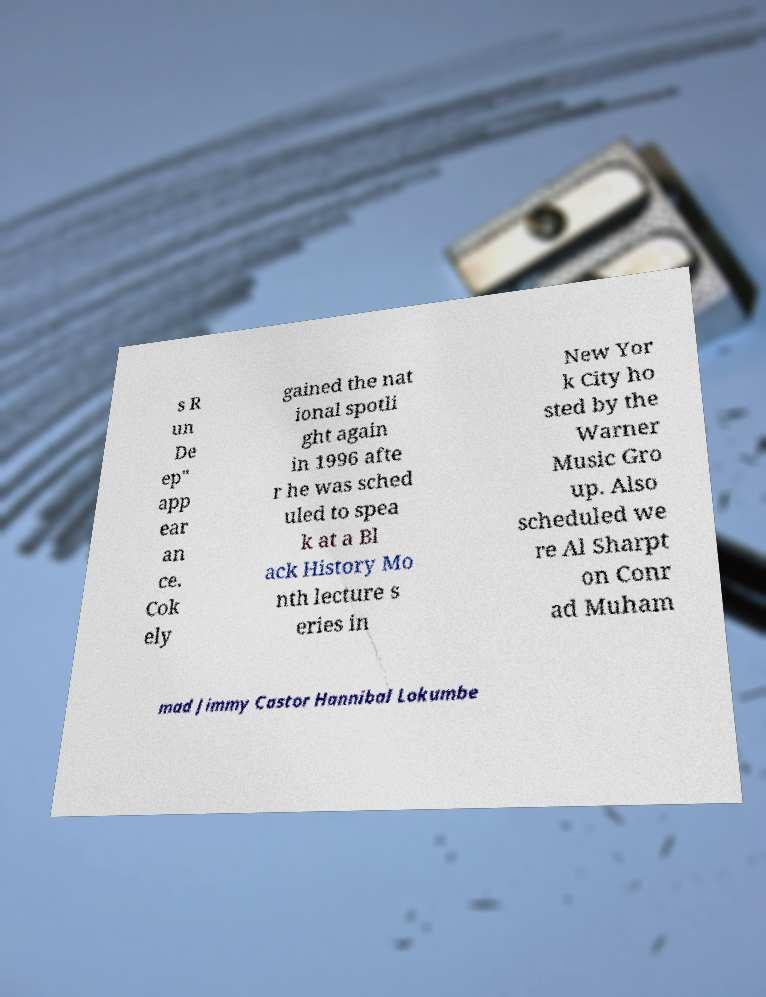For documentation purposes, I need the text within this image transcribed. Could you provide that? s R un De ep" app ear an ce. Cok ely gained the nat ional spotli ght again in 1996 afte r he was sched uled to spea k at a Bl ack History Mo nth lecture s eries in New Yor k City ho sted by the Warner Music Gro up. Also scheduled we re Al Sharpt on Conr ad Muham mad Jimmy Castor Hannibal Lokumbe 